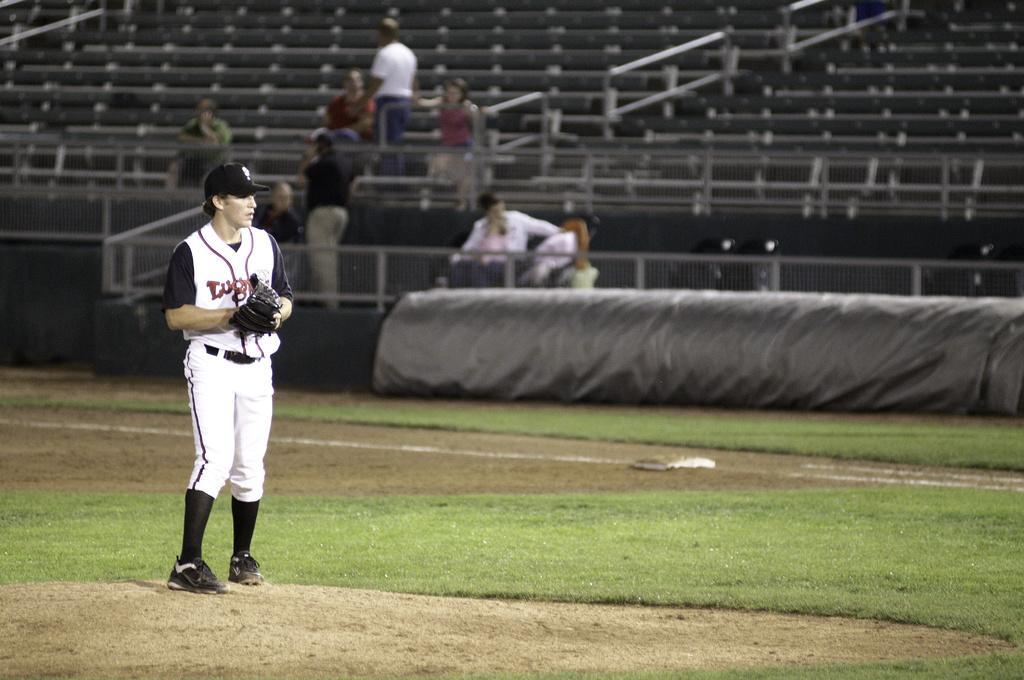Could you give a brief overview of what you see in this image? In this image there is a player standing on a ground, in the background there are few people sitting on chairs and two persons are standing. 